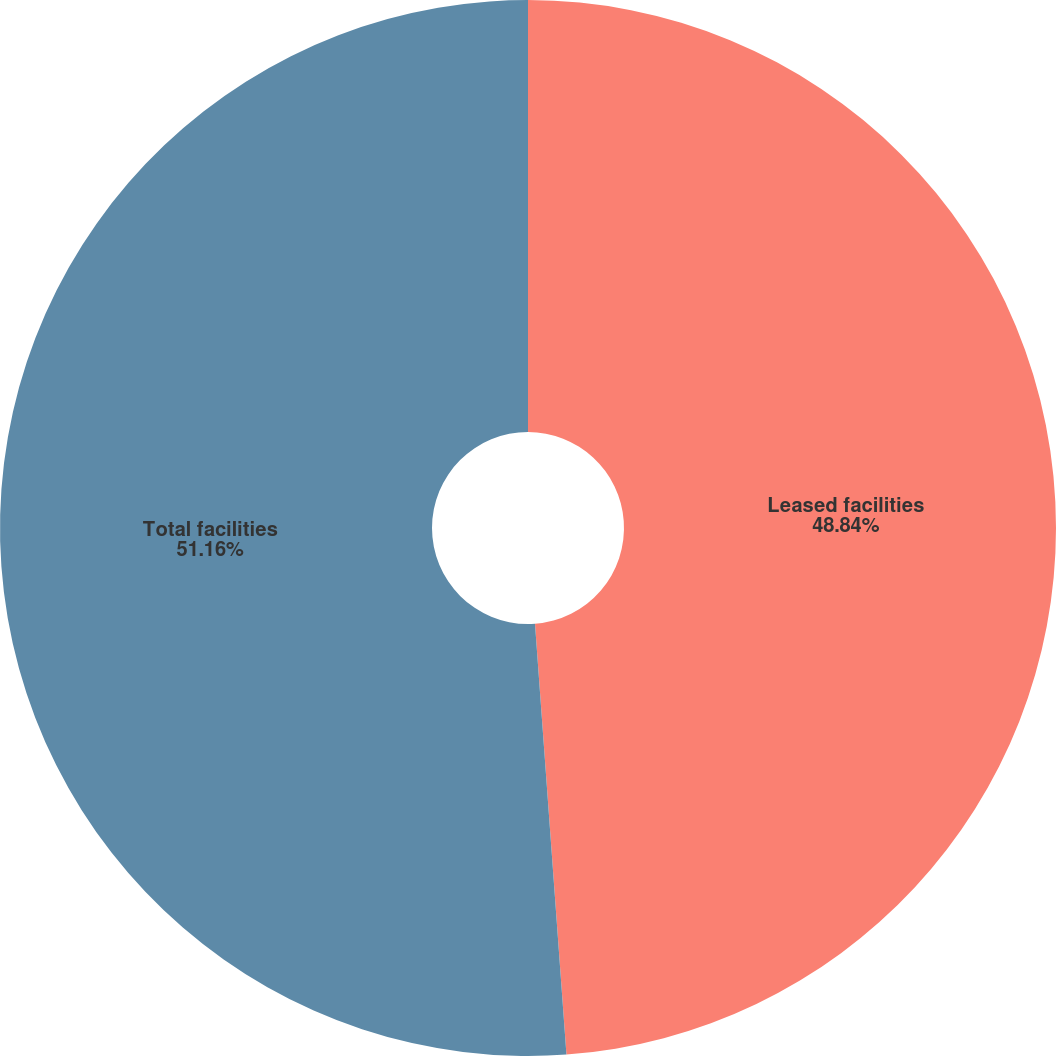<chart> <loc_0><loc_0><loc_500><loc_500><pie_chart><fcel>Leased facilities<fcel>Total facilities<nl><fcel>48.84%<fcel>51.16%<nl></chart> 